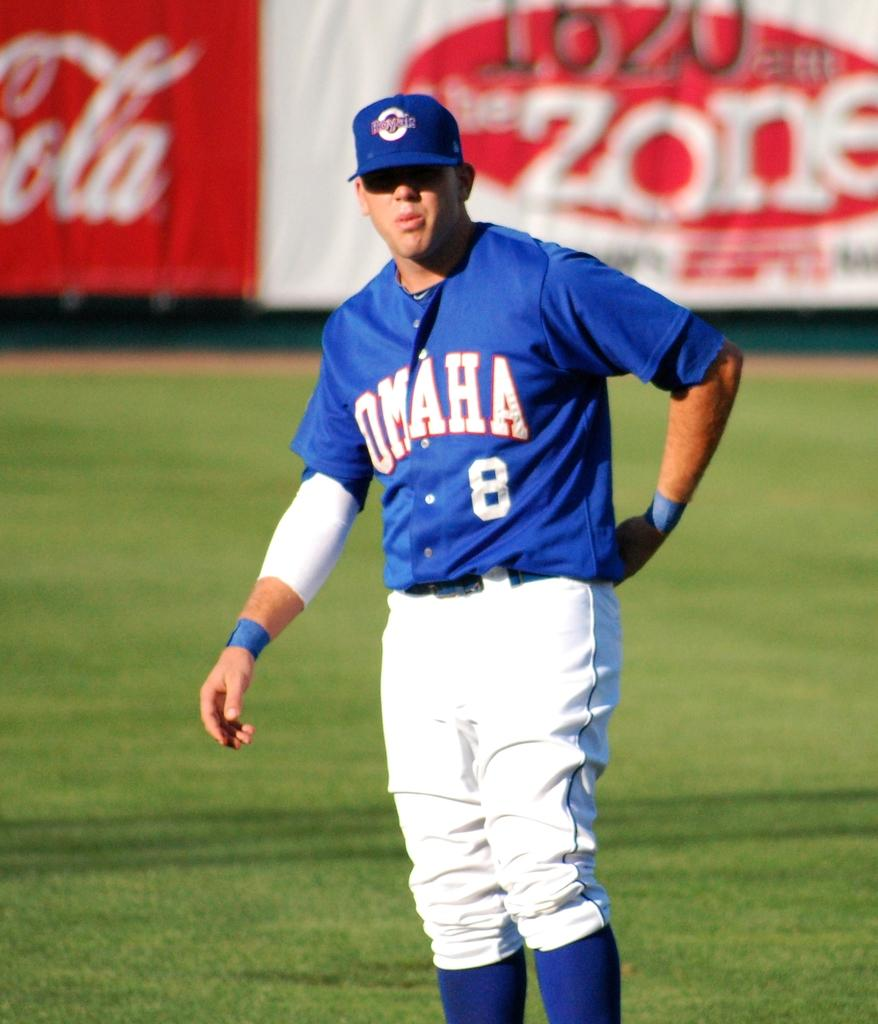<image>
Share a concise interpretation of the image provided. Omaha player number eight adjusts his pants as he looks at someone across the field. 